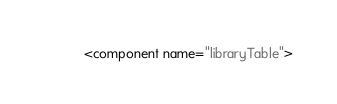Convert code to text. <code><loc_0><loc_0><loc_500><loc_500><_XML_><component name="libraryTable"></code> 